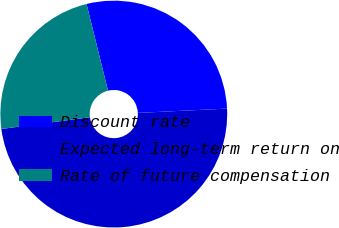Convert chart to OTSL. <chart><loc_0><loc_0><loc_500><loc_500><pie_chart><fcel>Discount rate<fcel>Expected long-term return on<fcel>Rate of future compensation<nl><fcel>28.09%<fcel>48.67%<fcel>23.24%<nl></chart> 